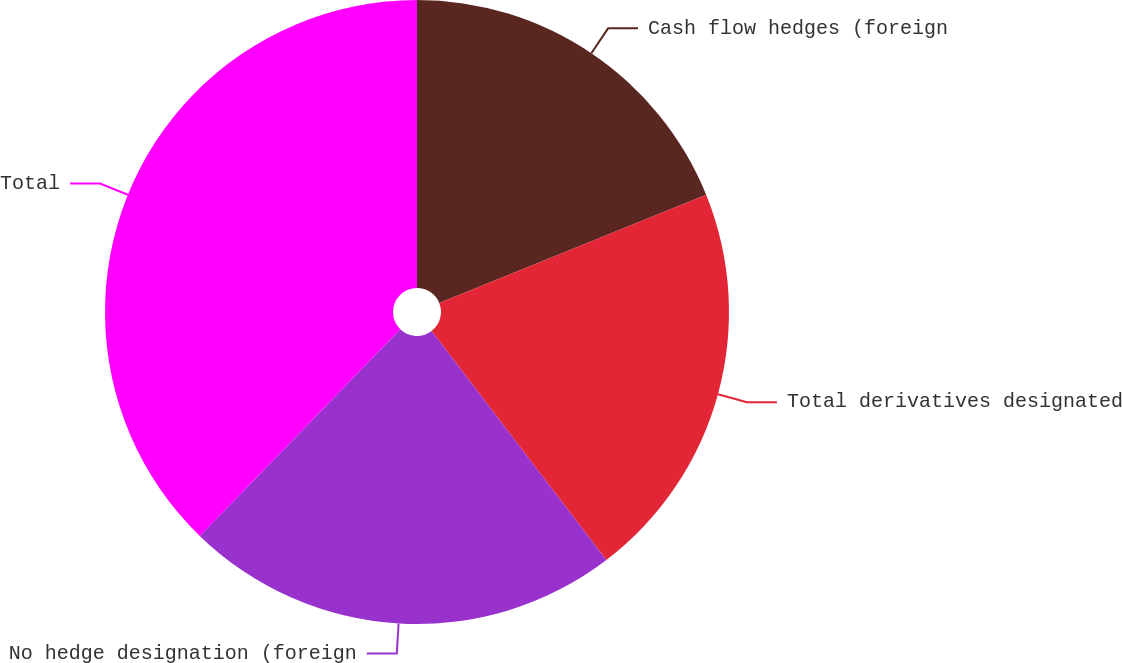Convert chart. <chart><loc_0><loc_0><loc_500><loc_500><pie_chart><fcel>Cash flow hedges (foreign<fcel>Total derivatives designated<fcel>No hedge designation (foreign<fcel>Total<nl><fcel>18.87%<fcel>20.75%<fcel>22.64%<fcel>37.74%<nl></chart> 